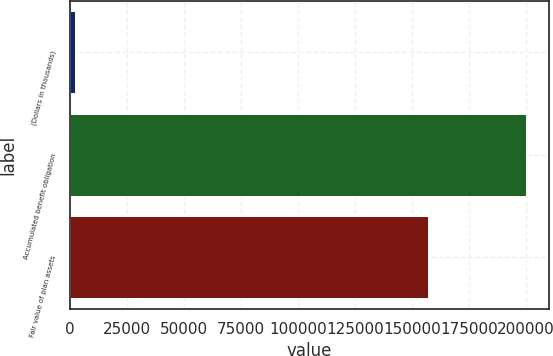<chart> <loc_0><loc_0><loc_500><loc_500><bar_chart><fcel>(Dollars in thousands)<fcel>Accumulated benefit obligation<fcel>Fair value of plan assets<nl><fcel>2014<fcel>200205<fcel>157090<nl></chart> 